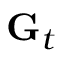<formula> <loc_0><loc_0><loc_500><loc_500>G _ { t }</formula> 